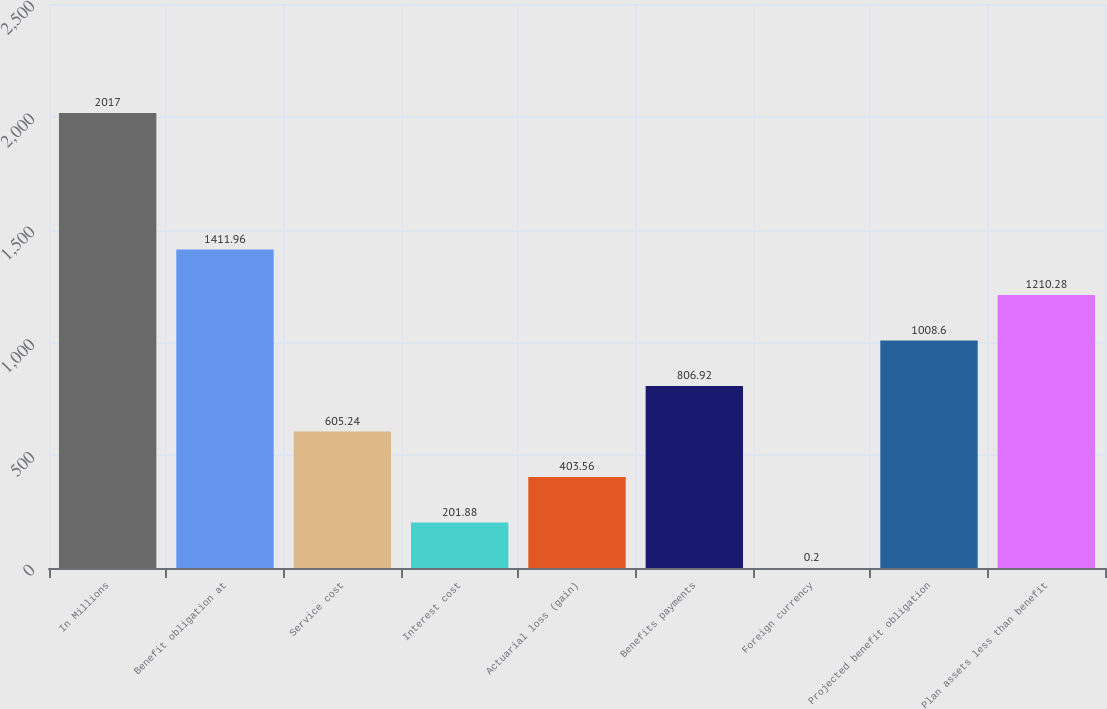<chart> <loc_0><loc_0><loc_500><loc_500><bar_chart><fcel>In Millions<fcel>Benefit obligation at<fcel>Service cost<fcel>Interest cost<fcel>Actuarial loss (gain)<fcel>Benefits payments<fcel>Foreign currency<fcel>Projected benefit obligation<fcel>Plan assets less than benefit<nl><fcel>2017<fcel>1411.96<fcel>605.24<fcel>201.88<fcel>403.56<fcel>806.92<fcel>0.2<fcel>1008.6<fcel>1210.28<nl></chart> 